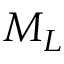Convert formula to latex. <formula><loc_0><loc_0><loc_500><loc_500>M _ { L }</formula> 